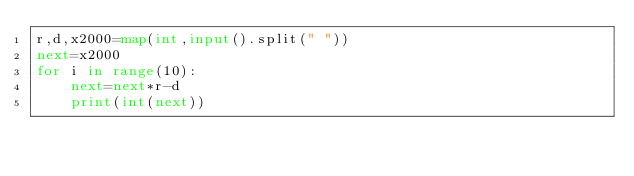<code> <loc_0><loc_0><loc_500><loc_500><_Python_>r,d,x2000=map(int,input().split(" "))
next=x2000
for i in range(10):
	next=next*r-d
	print(int(next))</code> 